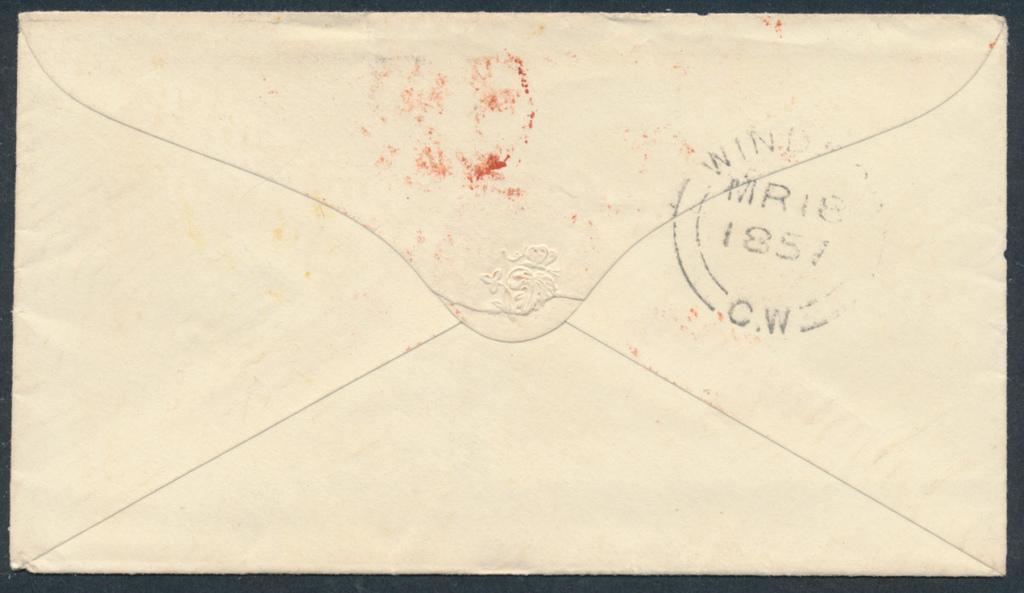<image>
Write a terse but informative summary of the picture. the back of an envelope with a stamp reading 1851 